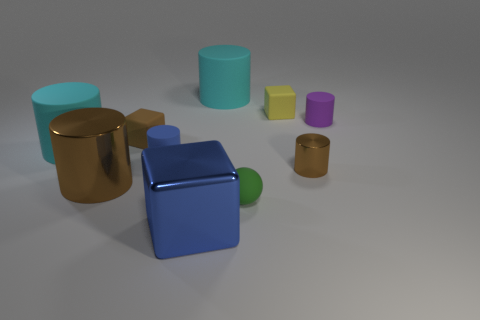What number of things are big green things or big cylinders that are right of the blue shiny block?
Keep it short and to the point. 1. The tiny thing that is the same color as the shiny cube is what shape?
Give a very brief answer. Cylinder. There is a small rubber cube in front of the tiny purple thing; what is its color?
Offer a very short reply. Brown. What number of things are matte cylinders to the left of the large brown cylinder or large green matte spheres?
Offer a very short reply. 1. There is another matte cylinder that is the same size as the blue matte cylinder; what is its color?
Offer a very short reply. Purple. Is the number of small blue rubber things left of the tiny purple rubber thing greater than the number of brown matte cylinders?
Ensure brevity in your answer.  Yes. There is a thing that is both left of the small yellow matte thing and behind the purple matte thing; what is it made of?
Your response must be concise. Rubber. Is the color of the thing that is behind the yellow object the same as the big rubber object in front of the purple thing?
Provide a short and direct response. Yes. What number of other things are there of the same size as the blue shiny object?
Keep it short and to the point. 3. There is a brown metallic thing that is left of the tiny cube that is to the left of the tiny blue rubber object; is there a tiny object in front of it?
Provide a succinct answer. Yes. 